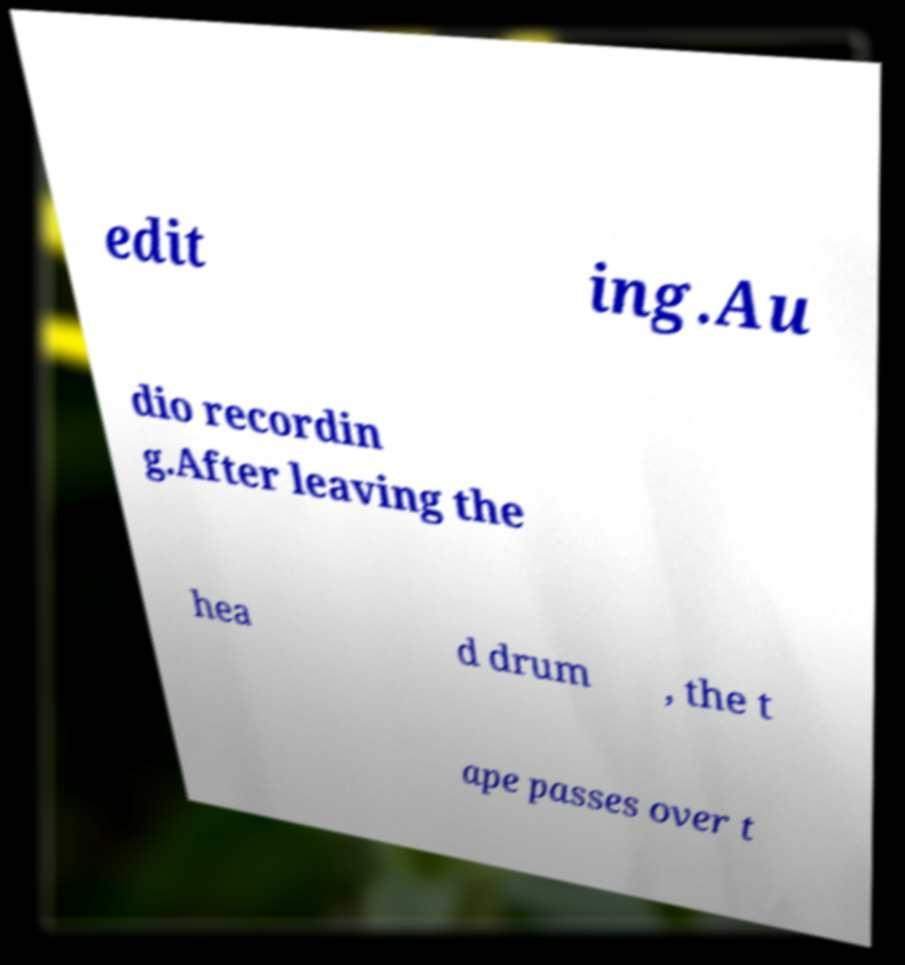I need the written content from this picture converted into text. Can you do that? edit ing.Au dio recordin g.After leaving the hea d drum , the t ape passes over t 